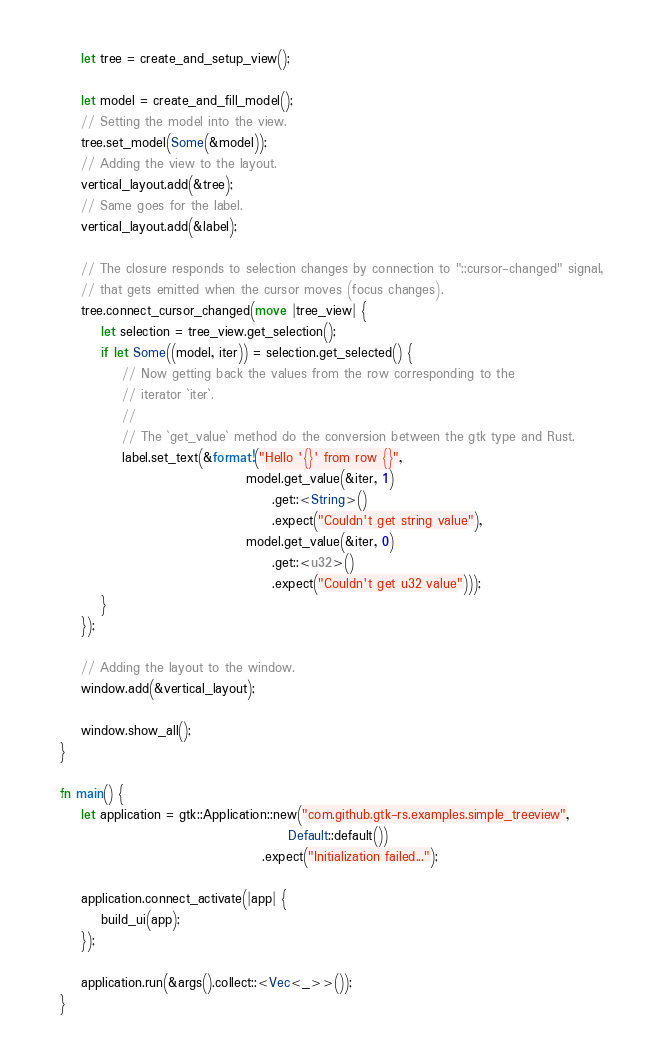Convert code to text. <code><loc_0><loc_0><loc_500><loc_500><_Rust_>    let tree = create_and_setup_view();

    let model = create_and_fill_model();
    // Setting the model into the view.
    tree.set_model(Some(&model));
    // Adding the view to the layout.
    vertical_layout.add(&tree);
    // Same goes for the label.
    vertical_layout.add(&label);

    // The closure responds to selection changes by connection to "::cursor-changed" signal,
    // that gets emitted when the cursor moves (focus changes).
    tree.connect_cursor_changed(move |tree_view| {
        let selection = tree_view.get_selection();
        if let Some((model, iter)) = selection.get_selected() {
            // Now getting back the values from the row corresponding to the
            // iterator `iter`.
            //
            // The `get_value` method do the conversion between the gtk type and Rust.
            label.set_text(&format!("Hello '{}' from row {}",
                                    model.get_value(&iter, 1)
                                         .get::<String>()
                                         .expect("Couldn't get string value"),
                                    model.get_value(&iter, 0)
                                         .get::<u32>()
                                         .expect("Couldn't get u32 value")));
        }
    });

    // Adding the layout to the window.
    window.add(&vertical_layout);

    window.show_all();
}

fn main() {
    let application = gtk::Application::new("com.github.gtk-rs.examples.simple_treeview",
                                            Default::default())
                                       .expect("Initialization failed...");

    application.connect_activate(|app| {
        build_ui(app);
    });

    application.run(&args().collect::<Vec<_>>());
}
</code> 